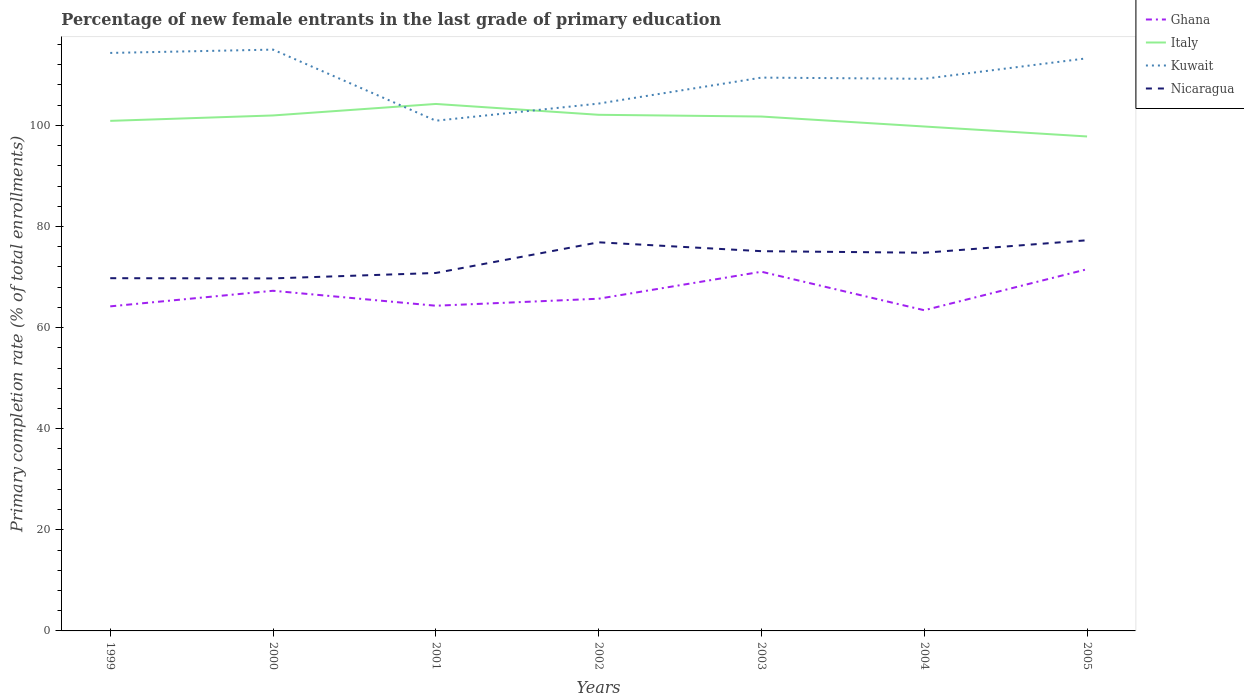How many different coloured lines are there?
Make the answer very short. 4. Across all years, what is the maximum percentage of new female entrants in Ghana?
Ensure brevity in your answer.  63.44. In which year was the percentage of new female entrants in Nicaragua maximum?
Offer a terse response. 2000. What is the total percentage of new female entrants in Ghana in the graph?
Your answer should be compact. -1.39. What is the difference between the highest and the second highest percentage of new female entrants in Kuwait?
Your response must be concise. 14.07. Is the percentage of new female entrants in Kuwait strictly greater than the percentage of new female entrants in Nicaragua over the years?
Keep it short and to the point. No. How many years are there in the graph?
Provide a succinct answer. 7. What is the difference between two consecutive major ticks on the Y-axis?
Give a very brief answer. 20. Are the values on the major ticks of Y-axis written in scientific E-notation?
Make the answer very short. No. Does the graph contain grids?
Your answer should be very brief. No. Where does the legend appear in the graph?
Your answer should be very brief. Top right. How many legend labels are there?
Ensure brevity in your answer.  4. What is the title of the graph?
Keep it short and to the point. Percentage of new female entrants in the last grade of primary education. What is the label or title of the Y-axis?
Offer a very short reply. Primary completion rate (% of total enrollments). What is the Primary completion rate (% of total enrollments) in Ghana in 1999?
Your answer should be very brief. 64.2. What is the Primary completion rate (% of total enrollments) in Italy in 1999?
Keep it short and to the point. 100.9. What is the Primary completion rate (% of total enrollments) of Kuwait in 1999?
Provide a short and direct response. 114.33. What is the Primary completion rate (% of total enrollments) of Nicaragua in 1999?
Keep it short and to the point. 69.77. What is the Primary completion rate (% of total enrollments) of Ghana in 2000?
Offer a very short reply. 67.29. What is the Primary completion rate (% of total enrollments) in Italy in 2000?
Offer a terse response. 101.97. What is the Primary completion rate (% of total enrollments) of Kuwait in 2000?
Make the answer very short. 114.99. What is the Primary completion rate (% of total enrollments) of Nicaragua in 2000?
Keep it short and to the point. 69.73. What is the Primary completion rate (% of total enrollments) of Ghana in 2001?
Your response must be concise. 64.33. What is the Primary completion rate (% of total enrollments) in Italy in 2001?
Offer a terse response. 104.24. What is the Primary completion rate (% of total enrollments) in Kuwait in 2001?
Provide a succinct answer. 100.93. What is the Primary completion rate (% of total enrollments) in Nicaragua in 2001?
Give a very brief answer. 70.81. What is the Primary completion rate (% of total enrollments) of Ghana in 2002?
Make the answer very short. 65.72. What is the Primary completion rate (% of total enrollments) of Italy in 2002?
Provide a short and direct response. 102.1. What is the Primary completion rate (% of total enrollments) of Kuwait in 2002?
Make the answer very short. 104.32. What is the Primary completion rate (% of total enrollments) in Nicaragua in 2002?
Give a very brief answer. 76.87. What is the Primary completion rate (% of total enrollments) in Ghana in 2003?
Offer a very short reply. 71.05. What is the Primary completion rate (% of total enrollments) of Italy in 2003?
Your answer should be very brief. 101.75. What is the Primary completion rate (% of total enrollments) of Kuwait in 2003?
Ensure brevity in your answer.  109.45. What is the Primary completion rate (% of total enrollments) of Nicaragua in 2003?
Your answer should be very brief. 75.12. What is the Primary completion rate (% of total enrollments) in Ghana in 2004?
Offer a very short reply. 63.44. What is the Primary completion rate (% of total enrollments) in Italy in 2004?
Make the answer very short. 99.78. What is the Primary completion rate (% of total enrollments) in Kuwait in 2004?
Ensure brevity in your answer.  109.22. What is the Primary completion rate (% of total enrollments) of Nicaragua in 2004?
Provide a short and direct response. 74.81. What is the Primary completion rate (% of total enrollments) in Ghana in 2005?
Offer a terse response. 71.55. What is the Primary completion rate (% of total enrollments) of Italy in 2005?
Your answer should be compact. 97.81. What is the Primary completion rate (% of total enrollments) of Kuwait in 2005?
Offer a terse response. 113.27. What is the Primary completion rate (% of total enrollments) of Nicaragua in 2005?
Provide a succinct answer. 77.28. Across all years, what is the maximum Primary completion rate (% of total enrollments) of Ghana?
Offer a terse response. 71.55. Across all years, what is the maximum Primary completion rate (% of total enrollments) in Italy?
Your answer should be compact. 104.24. Across all years, what is the maximum Primary completion rate (% of total enrollments) in Kuwait?
Provide a short and direct response. 114.99. Across all years, what is the maximum Primary completion rate (% of total enrollments) of Nicaragua?
Make the answer very short. 77.28. Across all years, what is the minimum Primary completion rate (% of total enrollments) of Ghana?
Keep it short and to the point. 63.44. Across all years, what is the minimum Primary completion rate (% of total enrollments) in Italy?
Your response must be concise. 97.81. Across all years, what is the minimum Primary completion rate (% of total enrollments) of Kuwait?
Ensure brevity in your answer.  100.93. Across all years, what is the minimum Primary completion rate (% of total enrollments) in Nicaragua?
Ensure brevity in your answer.  69.73. What is the total Primary completion rate (% of total enrollments) of Ghana in the graph?
Your answer should be compact. 467.57. What is the total Primary completion rate (% of total enrollments) of Italy in the graph?
Give a very brief answer. 708.55. What is the total Primary completion rate (% of total enrollments) in Kuwait in the graph?
Offer a terse response. 766.51. What is the total Primary completion rate (% of total enrollments) in Nicaragua in the graph?
Provide a succinct answer. 514.4. What is the difference between the Primary completion rate (% of total enrollments) in Ghana in 1999 and that in 2000?
Give a very brief answer. -3.08. What is the difference between the Primary completion rate (% of total enrollments) of Italy in 1999 and that in 2000?
Provide a succinct answer. -1.07. What is the difference between the Primary completion rate (% of total enrollments) of Kuwait in 1999 and that in 2000?
Your answer should be compact. -0.66. What is the difference between the Primary completion rate (% of total enrollments) in Nicaragua in 1999 and that in 2000?
Your response must be concise. 0.04. What is the difference between the Primary completion rate (% of total enrollments) in Ghana in 1999 and that in 2001?
Ensure brevity in your answer.  -0.12. What is the difference between the Primary completion rate (% of total enrollments) in Italy in 1999 and that in 2001?
Offer a terse response. -3.34. What is the difference between the Primary completion rate (% of total enrollments) in Kuwait in 1999 and that in 2001?
Offer a terse response. 13.41. What is the difference between the Primary completion rate (% of total enrollments) in Nicaragua in 1999 and that in 2001?
Your response must be concise. -1.03. What is the difference between the Primary completion rate (% of total enrollments) in Ghana in 1999 and that in 2002?
Your response must be concise. -1.51. What is the difference between the Primary completion rate (% of total enrollments) in Italy in 1999 and that in 2002?
Provide a short and direct response. -1.2. What is the difference between the Primary completion rate (% of total enrollments) of Kuwait in 1999 and that in 2002?
Make the answer very short. 10.02. What is the difference between the Primary completion rate (% of total enrollments) of Nicaragua in 1999 and that in 2002?
Offer a terse response. -7.1. What is the difference between the Primary completion rate (% of total enrollments) in Ghana in 1999 and that in 2003?
Your response must be concise. -6.85. What is the difference between the Primary completion rate (% of total enrollments) of Italy in 1999 and that in 2003?
Your answer should be compact. -0.86. What is the difference between the Primary completion rate (% of total enrollments) of Kuwait in 1999 and that in 2003?
Your response must be concise. 4.88. What is the difference between the Primary completion rate (% of total enrollments) of Nicaragua in 1999 and that in 2003?
Keep it short and to the point. -5.34. What is the difference between the Primary completion rate (% of total enrollments) in Ghana in 1999 and that in 2004?
Your response must be concise. 0.77. What is the difference between the Primary completion rate (% of total enrollments) of Italy in 1999 and that in 2004?
Make the answer very short. 1.12. What is the difference between the Primary completion rate (% of total enrollments) of Kuwait in 1999 and that in 2004?
Provide a succinct answer. 5.12. What is the difference between the Primary completion rate (% of total enrollments) of Nicaragua in 1999 and that in 2004?
Make the answer very short. -5.03. What is the difference between the Primary completion rate (% of total enrollments) in Ghana in 1999 and that in 2005?
Give a very brief answer. -7.34. What is the difference between the Primary completion rate (% of total enrollments) in Italy in 1999 and that in 2005?
Give a very brief answer. 3.09. What is the difference between the Primary completion rate (% of total enrollments) in Kuwait in 1999 and that in 2005?
Your response must be concise. 1.06. What is the difference between the Primary completion rate (% of total enrollments) in Nicaragua in 1999 and that in 2005?
Your response must be concise. -7.5. What is the difference between the Primary completion rate (% of total enrollments) of Ghana in 2000 and that in 2001?
Your answer should be very brief. 2.96. What is the difference between the Primary completion rate (% of total enrollments) in Italy in 2000 and that in 2001?
Provide a short and direct response. -2.27. What is the difference between the Primary completion rate (% of total enrollments) in Kuwait in 2000 and that in 2001?
Provide a short and direct response. 14.07. What is the difference between the Primary completion rate (% of total enrollments) of Nicaragua in 2000 and that in 2001?
Your response must be concise. -1.07. What is the difference between the Primary completion rate (% of total enrollments) in Ghana in 2000 and that in 2002?
Your answer should be very brief. 1.57. What is the difference between the Primary completion rate (% of total enrollments) of Italy in 2000 and that in 2002?
Your answer should be compact. -0.13. What is the difference between the Primary completion rate (% of total enrollments) of Kuwait in 2000 and that in 2002?
Your answer should be very brief. 10.68. What is the difference between the Primary completion rate (% of total enrollments) in Nicaragua in 2000 and that in 2002?
Your answer should be very brief. -7.14. What is the difference between the Primary completion rate (% of total enrollments) of Ghana in 2000 and that in 2003?
Keep it short and to the point. -3.77. What is the difference between the Primary completion rate (% of total enrollments) of Italy in 2000 and that in 2003?
Your answer should be compact. 0.21. What is the difference between the Primary completion rate (% of total enrollments) in Kuwait in 2000 and that in 2003?
Your answer should be compact. 5.54. What is the difference between the Primary completion rate (% of total enrollments) in Nicaragua in 2000 and that in 2003?
Provide a short and direct response. -5.38. What is the difference between the Primary completion rate (% of total enrollments) in Ghana in 2000 and that in 2004?
Offer a terse response. 3.85. What is the difference between the Primary completion rate (% of total enrollments) in Italy in 2000 and that in 2004?
Keep it short and to the point. 2.19. What is the difference between the Primary completion rate (% of total enrollments) of Kuwait in 2000 and that in 2004?
Your answer should be compact. 5.78. What is the difference between the Primary completion rate (% of total enrollments) of Nicaragua in 2000 and that in 2004?
Offer a terse response. -5.07. What is the difference between the Primary completion rate (% of total enrollments) in Ghana in 2000 and that in 2005?
Provide a short and direct response. -4.26. What is the difference between the Primary completion rate (% of total enrollments) in Italy in 2000 and that in 2005?
Give a very brief answer. 4.16. What is the difference between the Primary completion rate (% of total enrollments) of Kuwait in 2000 and that in 2005?
Offer a very short reply. 1.72. What is the difference between the Primary completion rate (% of total enrollments) in Nicaragua in 2000 and that in 2005?
Your answer should be very brief. -7.54. What is the difference between the Primary completion rate (% of total enrollments) in Ghana in 2001 and that in 2002?
Offer a very short reply. -1.39. What is the difference between the Primary completion rate (% of total enrollments) of Italy in 2001 and that in 2002?
Your answer should be compact. 2.14. What is the difference between the Primary completion rate (% of total enrollments) of Kuwait in 2001 and that in 2002?
Your answer should be compact. -3.39. What is the difference between the Primary completion rate (% of total enrollments) in Nicaragua in 2001 and that in 2002?
Make the answer very short. -6.07. What is the difference between the Primary completion rate (% of total enrollments) in Ghana in 2001 and that in 2003?
Give a very brief answer. -6.73. What is the difference between the Primary completion rate (% of total enrollments) in Italy in 2001 and that in 2003?
Provide a short and direct response. 2.49. What is the difference between the Primary completion rate (% of total enrollments) of Kuwait in 2001 and that in 2003?
Keep it short and to the point. -8.53. What is the difference between the Primary completion rate (% of total enrollments) of Nicaragua in 2001 and that in 2003?
Keep it short and to the point. -4.31. What is the difference between the Primary completion rate (% of total enrollments) in Ghana in 2001 and that in 2004?
Offer a very short reply. 0.89. What is the difference between the Primary completion rate (% of total enrollments) of Italy in 2001 and that in 2004?
Make the answer very short. 4.46. What is the difference between the Primary completion rate (% of total enrollments) of Kuwait in 2001 and that in 2004?
Provide a short and direct response. -8.29. What is the difference between the Primary completion rate (% of total enrollments) of Nicaragua in 2001 and that in 2004?
Keep it short and to the point. -4. What is the difference between the Primary completion rate (% of total enrollments) in Ghana in 2001 and that in 2005?
Give a very brief answer. -7.22. What is the difference between the Primary completion rate (% of total enrollments) in Italy in 2001 and that in 2005?
Your answer should be compact. 6.43. What is the difference between the Primary completion rate (% of total enrollments) of Kuwait in 2001 and that in 2005?
Your answer should be compact. -12.35. What is the difference between the Primary completion rate (% of total enrollments) of Nicaragua in 2001 and that in 2005?
Offer a terse response. -6.47. What is the difference between the Primary completion rate (% of total enrollments) of Ghana in 2002 and that in 2003?
Ensure brevity in your answer.  -5.34. What is the difference between the Primary completion rate (% of total enrollments) of Italy in 2002 and that in 2003?
Give a very brief answer. 0.34. What is the difference between the Primary completion rate (% of total enrollments) of Kuwait in 2002 and that in 2003?
Keep it short and to the point. -5.14. What is the difference between the Primary completion rate (% of total enrollments) of Nicaragua in 2002 and that in 2003?
Offer a very short reply. 1.76. What is the difference between the Primary completion rate (% of total enrollments) in Ghana in 2002 and that in 2004?
Provide a succinct answer. 2.28. What is the difference between the Primary completion rate (% of total enrollments) of Italy in 2002 and that in 2004?
Ensure brevity in your answer.  2.32. What is the difference between the Primary completion rate (% of total enrollments) of Kuwait in 2002 and that in 2004?
Make the answer very short. -4.9. What is the difference between the Primary completion rate (% of total enrollments) of Nicaragua in 2002 and that in 2004?
Make the answer very short. 2.06. What is the difference between the Primary completion rate (% of total enrollments) of Ghana in 2002 and that in 2005?
Provide a succinct answer. -5.83. What is the difference between the Primary completion rate (% of total enrollments) of Italy in 2002 and that in 2005?
Ensure brevity in your answer.  4.29. What is the difference between the Primary completion rate (% of total enrollments) of Kuwait in 2002 and that in 2005?
Make the answer very short. -8.96. What is the difference between the Primary completion rate (% of total enrollments) in Nicaragua in 2002 and that in 2005?
Offer a very short reply. -0.41. What is the difference between the Primary completion rate (% of total enrollments) in Ghana in 2003 and that in 2004?
Offer a terse response. 7.62. What is the difference between the Primary completion rate (% of total enrollments) of Italy in 2003 and that in 2004?
Give a very brief answer. 1.97. What is the difference between the Primary completion rate (% of total enrollments) of Kuwait in 2003 and that in 2004?
Provide a succinct answer. 0.24. What is the difference between the Primary completion rate (% of total enrollments) in Nicaragua in 2003 and that in 2004?
Provide a succinct answer. 0.31. What is the difference between the Primary completion rate (% of total enrollments) in Ghana in 2003 and that in 2005?
Keep it short and to the point. -0.49. What is the difference between the Primary completion rate (% of total enrollments) in Italy in 2003 and that in 2005?
Give a very brief answer. 3.94. What is the difference between the Primary completion rate (% of total enrollments) in Kuwait in 2003 and that in 2005?
Keep it short and to the point. -3.82. What is the difference between the Primary completion rate (% of total enrollments) in Nicaragua in 2003 and that in 2005?
Provide a succinct answer. -2.16. What is the difference between the Primary completion rate (% of total enrollments) of Ghana in 2004 and that in 2005?
Your response must be concise. -8.11. What is the difference between the Primary completion rate (% of total enrollments) of Italy in 2004 and that in 2005?
Your answer should be compact. 1.97. What is the difference between the Primary completion rate (% of total enrollments) of Kuwait in 2004 and that in 2005?
Keep it short and to the point. -4.06. What is the difference between the Primary completion rate (% of total enrollments) in Nicaragua in 2004 and that in 2005?
Make the answer very short. -2.47. What is the difference between the Primary completion rate (% of total enrollments) in Ghana in 1999 and the Primary completion rate (% of total enrollments) in Italy in 2000?
Your answer should be very brief. -37.76. What is the difference between the Primary completion rate (% of total enrollments) of Ghana in 1999 and the Primary completion rate (% of total enrollments) of Kuwait in 2000?
Offer a terse response. -50.79. What is the difference between the Primary completion rate (% of total enrollments) in Ghana in 1999 and the Primary completion rate (% of total enrollments) in Nicaragua in 2000?
Your answer should be very brief. -5.53. What is the difference between the Primary completion rate (% of total enrollments) of Italy in 1999 and the Primary completion rate (% of total enrollments) of Kuwait in 2000?
Your response must be concise. -14.1. What is the difference between the Primary completion rate (% of total enrollments) in Italy in 1999 and the Primary completion rate (% of total enrollments) in Nicaragua in 2000?
Provide a short and direct response. 31.16. What is the difference between the Primary completion rate (% of total enrollments) of Kuwait in 1999 and the Primary completion rate (% of total enrollments) of Nicaragua in 2000?
Make the answer very short. 44.6. What is the difference between the Primary completion rate (% of total enrollments) of Ghana in 1999 and the Primary completion rate (% of total enrollments) of Italy in 2001?
Offer a terse response. -40.04. What is the difference between the Primary completion rate (% of total enrollments) in Ghana in 1999 and the Primary completion rate (% of total enrollments) in Kuwait in 2001?
Provide a succinct answer. -36.72. What is the difference between the Primary completion rate (% of total enrollments) in Ghana in 1999 and the Primary completion rate (% of total enrollments) in Nicaragua in 2001?
Offer a very short reply. -6.6. What is the difference between the Primary completion rate (% of total enrollments) of Italy in 1999 and the Primary completion rate (% of total enrollments) of Kuwait in 2001?
Make the answer very short. -0.03. What is the difference between the Primary completion rate (% of total enrollments) of Italy in 1999 and the Primary completion rate (% of total enrollments) of Nicaragua in 2001?
Your answer should be very brief. 30.09. What is the difference between the Primary completion rate (% of total enrollments) in Kuwait in 1999 and the Primary completion rate (% of total enrollments) in Nicaragua in 2001?
Keep it short and to the point. 43.53. What is the difference between the Primary completion rate (% of total enrollments) of Ghana in 1999 and the Primary completion rate (% of total enrollments) of Italy in 2002?
Offer a very short reply. -37.89. What is the difference between the Primary completion rate (% of total enrollments) of Ghana in 1999 and the Primary completion rate (% of total enrollments) of Kuwait in 2002?
Give a very brief answer. -40.11. What is the difference between the Primary completion rate (% of total enrollments) of Ghana in 1999 and the Primary completion rate (% of total enrollments) of Nicaragua in 2002?
Your response must be concise. -12.67. What is the difference between the Primary completion rate (% of total enrollments) in Italy in 1999 and the Primary completion rate (% of total enrollments) in Kuwait in 2002?
Make the answer very short. -3.42. What is the difference between the Primary completion rate (% of total enrollments) of Italy in 1999 and the Primary completion rate (% of total enrollments) of Nicaragua in 2002?
Give a very brief answer. 24.02. What is the difference between the Primary completion rate (% of total enrollments) of Kuwait in 1999 and the Primary completion rate (% of total enrollments) of Nicaragua in 2002?
Provide a succinct answer. 37.46. What is the difference between the Primary completion rate (% of total enrollments) in Ghana in 1999 and the Primary completion rate (% of total enrollments) in Italy in 2003?
Keep it short and to the point. -37.55. What is the difference between the Primary completion rate (% of total enrollments) in Ghana in 1999 and the Primary completion rate (% of total enrollments) in Kuwait in 2003?
Give a very brief answer. -45.25. What is the difference between the Primary completion rate (% of total enrollments) of Ghana in 1999 and the Primary completion rate (% of total enrollments) of Nicaragua in 2003?
Offer a very short reply. -10.91. What is the difference between the Primary completion rate (% of total enrollments) in Italy in 1999 and the Primary completion rate (% of total enrollments) in Kuwait in 2003?
Ensure brevity in your answer.  -8.56. What is the difference between the Primary completion rate (% of total enrollments) of Italy in 1999 and the Primary completion rate (% of total enrollments) of Nicaragua in 2003?
Ensure brevity in your answer.  25.78. What is the difference between the Primary completion rate (% of total enrollments) in Kuwait in 1999 and the Primary completion rate (% of total enrollments) in Nicaragua in 2003?
Give a very brief answer. 39.22. What is the difference between the Primary completion rate (% of total enrollments) in Ghana in 1999 and the Primary completion rate (% of total enrollments) in Italy in 2004?
Keep it short and to the point. -35.58. What is the difference between the Primary completion rate (% of total enrollments) of Ghana in 1999 and the Primary completion rate (% of total enrollments) of Kuwait in 2004?
Your answer should be very brief. -45.01. What is the difference between the Primary completion rate (% of total enrollments) in Ghana in 1999 and the Primary completion rate (% of total enrollments) in Nicaragua in 2004?
Keep it short and to the point. -10.61. What is the difference between the Primary completion rate (% of total enrollments) in Italy in 1999 and the Primary completion rate (% of total enrollments) in Kuwait in 2004?
Keep it short and to the point. -8.32. What is the difference between the Primary completion rate (% of total enrollments) of Italy in 1999 and the Primary completion rate (% of total enrollments) of Nicaragua in 2004?
Your answer should be compact. 26.09. What is the difference between the Primary completion rate (% of total enrollments) in Kuwait in 1999 and the Primary completion rate (% of total enrollments) in Nicaragua in 2004?
Provide a succinct answer. 39.52. What is the difference between the Primary completion rate (% of total enrollments) of Ghana in 1999 and the Primary completion rate (% of total enrollments) of Italy in 2005?
Provide a short and direct response. -33.61. What is the difference between the Primary completion rate (% of total enrollments) of Ghana in 1999 and the Primary completion rate (% of total enrollments) of Kuwait in 2005?
Provide a short and direct response. -49.07. What is the difference between the Primary completion rate (% of total enrollments) of Ghana in 1999 and the Primary completion rate (% of total enrollments) of Nicaragua in 2005?
Keep it short and to the point. -13.08. What is the difference between the Primary completion rate (% of total enrollments) in Italy in 1999 and the Primary completion rate (% of total enrollments) in Kuwait in 2005?
Provide a succinct answer. -12.38. What is the difference between the Primary completion rate (% of total enrollments) of Italy in 1999 and the Primary completion rate (% of total enrollments) of Nicaragua in 2005?
Offer a very short reply. 23.62. What is the difference between the Primary completion rate (% of total enrollments) in Kuwait in 1999 and the Primary completion rate (% of total enrollments) in Nicaragua in 2005?
Your answer should be very brief. 37.06. What is the difference between the Primary completion rate (% of total enrollments) of Ghana in 2000 and the Primary completion rate (% of total enrollments) of Italy in 2001?
Offer a very short reply. -36.96. What is the difference between the Primary completion rate (% of total enrollments) in Ghana in 2000 and the Primary completion rate (% of total enrollments) in Kuwait in 2001?
Keep it short and to the point. -33.64. What is the difference between the Primary completion rate (% of total enrollments) of Ghana in 2000 and the Primary completion rate (% of total enrollments) of Nicaragua in 2001?
Your response must be concise. -3.52. What is the difference between the Primary completion rate (% of total enrollments) of Italy in 2000 and the Primary completion rate (% of total enrollments) of Kuwait in 2001?
Offer a very short reply. 1.04. What is the difference between the Primary completion rate (% of total enrollments) of Italy in 2000 and the Primary completion rate (% of total enrollments) of Nicaragua in 2001?
Offer a terse response. 31.16. What is the difference between the Primary completion rate (% of total enrollments) in Kuwait in 2000 and the Primary completion rate (% of total enrollments) in Nicaragua in 2001?
Provide a short and direct response. 44.18. What is the difference between the Primary completion rate (% of total enrollments) in Ghana in 2000 and the Primary completion rate (% of total enrollments) in Italy in 2002?
Offer a terse response. -34.81. What is the difference between the Primary completion rate (% of total enrollments) of Ghana in 2000 and the Primary completion rate (% of total enrollments) of Kuwait in 2002?
Your response must be concise. -37.03. What is the difference between the Primary completion rate (% of total enrollments) of Ghana in 2000 and the Primary completion rate (% of total enrollments) of Nicaragua in 2002?
Make the answer very short. -9.59. What is the difference between the Primary completion rate (% of total enrollments) in Italy in 2000 and the Primary completion rate (% of total enrollments) in Kuwait in 2002?
Provide a short and direct response. -2.35. What is the difference between the Primary completion rate (% of total enrollments) of Italy in 2000 and the Primary completion rate (% of total enrollments) of Nicaragua in 2002?
Your answer should be very brief. 25.09. What is the difference between the Primary completion rate (% of total enrollments) in Kuwait in 2000 and the Primary completion rate (% of total enrollments) in Nicaragua in 2002?
Your response must be concise. 38.12. What is the difference between the Primary completion rate (% of total enrollments) in Ghana in 2000 and the Primary completion rate (% of total enrollments) in Italy in 2003?
Offer a very short reply. -34.47. What is the difference between the Primary completion rate (% of total enrollments) in Ghana in 2000 and the Primary completion rate (% of total enrollments) in Kuwait in 2003?
Offer a terse response. -42.17. What is the difference between the Primary completion rate (% of total enrollments) of Ghana in 2000 and the Primary completion rate (% of total enrollments) of Nicaragua in 2003?
Your response must be concise. -7.83. What is the difference between the Primary completion rate (% of total enrollments) of Italy in 2000 and the Primary completion rate (% of total enrollments) of Kuwait in 2003?
Keep it short and to the point. -7.49. What is the difference between the Primary completion rate (% of total enrollments) in Italy in 2000 and the Primary completion rate (% of total enrollments) in Nicaragua in 2003?
Make the answer very short. 26.85. What is the difference between the Primary completion rate (% of total enrollments) of Kuwait in 2000 and the Primary completion rate (% of total enrollments) of Nicaragua in 2003?
Ensure brevity in your answer.  39.87. What is the difference between the Primary completion rate (% of total enrollments) in Ghana in 2000 and the Primary completion rate (% of total enrollments) in Italy in 2004?
Your response must be concise. -32.5. What is the difference between the Primary completion rate (% of total enrollments) in Ghana in 2000 and the Primary completion rate (% of total enrollments) in Kuwait in 2004?
Make the answer very short. -41.93. What is the difference between the Primary completion rate (% of total enrollments) in Ghana in 2000 and the Primary completion rate (% of total enrollments) in Nicaragua in 2004?
Ensure brevity in your answer.  -7.52. What is the difference between the Primary completion rate (% of total enrollments) in Italy in 2000 and the Primary completion rate (% of total enrollments) in Kuwait in 2004?
Your answer should be very brief. -7.25. What is the difference between the Primary completion rate (% of total enrollments) in Italy in 2000 and the Primary completion rate (% of total enrollments) in Nicaragua in 2004?
Your answer should be very brief. 27.16. What is the difference between the Primary completion rate (% of total enrollments) of Kuwait in 2000 and the Primary completion rate (% of total enrollments) of Nicaragua in 2004?
Keep it short and to the point. 40.18. What is the difference between the Primary completion rate (% of total enrollments) in Ghana in 2000 and the Primary completion rate (% of total enrollments) in Italy in 2005?
Keep it short and to the point. -30.53. What is the difference between the Primary completion rate (% of total enrollments) in Ghana in 2000 and the Primary completion rate (% of total enrollments) in Kuwait in 2005?
Provide a succinct answer. -45.99. What is the difference between the Primary completion rate (% of total enrollments) of Ghana in 2000 and the Primary completion rate (% of total enrollments) of Nicaragua in 2005?
Provide a succinct answer. -9.99. What is the difference between the Primary completion rate (% of total enrollments) in Italy in 2000 and the Primary completion rate (% of total enrollments) in Kuwait in 2005?
Keep it short and to the point. -11.31. What is the difference between the Primary completion rate (% of total enrollments) of Italy in 2000 and the Primary completion rate (% of total enrollments) of Nicaragua in 2005?
Your response must be concise. 24.69. What is the difference between the Primary completion rate (% of total enrollments) in Kuwait in 2000 and the Primary completion rate (% of total enrollments) in Nicaragua in 2005?
Your answer should be very brief. 37.71. What is the difference between the Primary completion rate (% of total enrollments) of Ghana in 2001 and the Primary completion rate (% of total enrollments) of Italy in 2002?
Your response must be concise. -37.77. What is the difference between the Primary completion rate (% of total enrollments) of Ghana in 2001 and the Primary completion rate (% of total enrollments) of Kuwait in 2002?
Offer a terse response. -39.99. What is the difference between the Primary completion rate (% of total enrollments) of Ghana in 2001 and the Primary completion rate (% of total enrollments) of Nicaragua in 2002?
Offer a terse response. -12.55. What is the difference between the Primary completion rate (% of total enrollments) of Italy in 2001 and the Primary completion rate (% of total enrollments) of Kuwait in 2002?
Keep it short and to the point. -0.08. What is the difference between the Primary completion rate (% of total enrollments) of Italy in 2001 and the Primary completion rate (% of total enrollments) of Nicaragua in 2002?
Your response must be concise. 27.37. What is the difference between the Primary completion rate (% of total enrollments) in Kuwait in 2001 and the Primary completion rate (% of total enrollments) in Nicaragua in 2002?
Provide a short and direct response. 24.05. What is the difference between the Primary completion rate (% of total enrollments) in Ghana in 2001 and the Primary completion rate (% of total enrollments) in Italy in 2003?
Keep it short and to the point. -37.43. What is the difference between the Primary completion rate (% of total enrollments) of Ghana in 2001 and the Primary completion rate (% of total enrollments) of Kuwait in 2003?
Give a very brief answer. -45.13. What is the difference between the Primary completion rate (% of total enrollments) in Ghana in 2001 and the Primary completion rate (% of total enrollments) in Nicaragua in 2003?
Keep it short and to the point. -10.79. What is the difference between the Primary completion rate (% of total enrollments) in Italy in 2001 and the Primary completion rate (% of total enrollments) in Kuwait in 2003?
Offer a very short reply. -5.21. What is the difference between the Primary completion rate (% of total enrollments) in Italy in 2001 and the Primary completion rate (% of total enrollments) in Nicaragua in 2003?
Keep it short and to the point. 29.12. What is the difference between the Primary completion rate (% of total enrollments) in Kuwait in 2001 and the Primary completion rate (% of total enrollments) in Nicaragua in 2003?
Your answer should be very brief. 25.81. What is the difference between the Primary completion rate (% of total enrollments) in Ghana in 2001 and the Primary completion rate (% of total enrollments) in Italy in 2004?
Your response must be concise. -35.45. What is the difference between the Primary completion rate (% of total enrollments) of Ghana in 2001 and the Primary completion rate (% of total enrollments) of Kuwait in 2004?
Keep it short and to the point. -44.89. What is the difference between the Primary completion rate (% of total enrollments) of Ghana in 2001 and the Primary completion rate (% of total enrollments) of Nicaragua in 2004?
Provide a short and direct response. -10.48. What is the difference between the Primary completion rate (% of total enrollments) in Italy in 2001 and the Primary completion rate (% of total enrollments) in Kuwait in 2004?
Offer a terse response. -4.98. What is the difference between the Primary completion rate (% of total enrollments) of Italy in 2001 and the Primary completion rate (% of total enrollments) of Nicaragua in 2004?
Your answer should be compact. 29.43. What is the difference between the Primary completion rate (% of total enrollments) in Kuwait in 2001 and the Primary completion rate (% of total enrollments) in Nicaragua in 2004?
Provide a succinct answer. 26.12. What is the difference between the Primary completion rate (% of total enrollments) in Ghana in 2001 and the Primary completion rate (% of total enrollments) in Italy in 2005?
Your response must be concise. -33.48. What is the difference between the Primary completion rate (% of total enrollments) in Ghana in 2001 and the Primary completion rate (% of total enrollments) in Kuwait in 2005?
Offer a very short reply. -48.95. What is the difference between the Primary completion rate (% of total enrollments) of Ghana in 2001 and the Primary completion rate (% of total enrollments) of Nicaragua in 2005?
Offer a very short reply. -12.95. What is the difference between the Primary completion rate (% of total enrollments) of Italy in 2001 and the Primary completion rate (% of total enrollments) of Kuwait in 2005?
Your answer should be very brief. -9.03. What is the difference between the Primary completion rate (% of total enrollments) in Italy in 2001 and the Primary completion rate (% of total enrollments) in Nicaragua in 2005?
Offer a terse response. 26.96. What is the difference between the Primary completion rate (% of total enrollments) of Kuwait in 2001 and the Primary completion rate (% of total enrollments) of Nicaragua in 2005?
Offer a very short reply. 23.65. What is the difference between the Primary completion rate (% of total enrollments) of Ghana in 2002 and the Primary completion rate (% of total enrollments) of Italy in 2003?
Make the answer very short. -36.04. What is the difference between the Primary completion rate (% of total enrollments) of Ghana in 2002 and the Primary completion rate (% of total enrollments) of Kuwait in 2003?
Provide a short and direct response. -43.74. What is the difference between the Primary completion rate (% of total enrollments) of Ghana in 2002 and the Primary completion rate (% of total enrollments) of Nicaragua in 2003?
Make the answer very short. -9.4. What is the difference between the Primary completion rate (% of total enrollments) of Italy in 2002 and the Primary completion rate (% of total enrollments) of Kuwait in 2003?
Your response must be concise. -7.36. What is the difference between the Primary completion rate (% of total enrollments) in Italy in 2002 and the Primary completion rate (% of total enrollments) in Nicaragua in 2003?
Keep it short and to the point. 26.98. What is the difference between the Primary completion rate (% of total enrollments) of Kuwait in 2002 and the Primary completion rate (% of total enrollments) of Nicaragua in 2003?
Keep it short and to the point. 29.2. What is the difference between the Primary completion rate (% of total enrollments) in Ghana in 2002 and the Primary completion rate (% of total enrollments) in Italy in 2004?
Give a very brief answer. -34.07. What is the difference between the Primary completion rate (% of total enrollments) in Ghana in 2002 and the Primary completion rate (% of total enrollments) in Kuwait in 2004?
Provide a short and direct response. -43.5. What is the difference between the Primary completion rate (% of total enrollments) of Ghana in 2002 and the Primary completion rate (% of total enrollments) of Nicaragua in 2004?
Offer a terse response. -9.09. What is the difference between the Primary completion rate (% of total enrollments) in Italy in 2002 and the Primary completion rate (% of total enrollments) in Kuwait in 2004?
Your response must be concise. -7.12. What is the difference between the Primary completion rate (% of total enrollments) of Italy in 2002 and the Primary completion rate (% of total enrollments) of Nicaragua in 2004?
Offer a terse response. 27.29. What is the difference between the Primary completion rate (% of total enrollments) of Kuwait in 2002 and the Primary completion rate (% of total enrollments) of Nicaragua in 2004?
Offer a very short reply. 29.51. What is the difference between the Primary completion rate (% of total enrollments) in Ghana in 2002 and the Primary completion rate (% of total enrollments) in Italy in 2005?
Provide a succinct answer. -32.1. What is the difference between the Primary completion rate (% of total enrollments) of Ghana in 2002 and the Primary completion rate (% of total enrollments) of Kuwait in 2005?
Your answer should be very brief. -47.56. What is the difference between the Primary completion rate (% of total enrollments) in Ghana in 2002 and the Primary completion rate (% of total enrollments) in Nicaragua in 2005?
Your response must be concise. -11.56. What is the difference between the Primary completion rate (% of total enrollments) in Italy in 2002 and the Primary completion rate (% of total enrollments) in Kuwait in 2005?
Ensure brevity in your answer.  -11.18. What is the difference between the Primary completion rate (% of total enrollments) of Italy in 2002 and the Primary completion rate (% of total enrollments) of Nicaragua in 2005?
Your answer should be compact. 24.82. What is the difference between the Primary completion rate (% of total enrollments) in Kuwait in 2002 and the Primary completion rate (% of total enrollments) in Nicaragua in 2005?
Offer a terse response. 27.04. What is the difference between the Primary completion rate (% of total enrollments) in Ghana in 2003 and the Primary completion rate (% of total enrollments) in Italy in 2004?
Your response must be concise. -28.73. What is the difference between the Primary completion rate (% of total enrollments) of Ghana in 2003 and the Primary completion rate (% of total enrollments) of Kuwait in 2004?
Keep it short and to the point. -38.16. What is the difference between the Primary completion rate (% of total enrollments) of Ghana in 2003 and the Primary completion rate (% of total enrollments) of Nicaragua in 2004?
Your response must be concise. -3.75. What is the difference between the Primary completion rate (% of total enrollments) of Italy in 2003 and the Primary completion rate (% of total enrollments) of Kuwait in 2004?
Offer a very short reply. -7.46. What is the difference between the Primary completion rate (% of total enrollments) of Italy in 2003 and the Primary completion rate (% of total enrollments) of Nicaragua in 2004?
Ensure brevity in your answer.  26.95. What is the difference between the Primary completion rate (% of total enrollments) in Kuwait in 2003 and the Primary completion rate (% of total enrollments) in Nicaragua in 2004?
Offer a terse response. 34.64. What is the difference between the Primary completion rate (% of total enrollments) in Ghana in 2003 and the Primary completion rate (% of total enrollments) in Italy in 2005?
Make the answer very short. -26.76. What is the difference between the Primary completion rate (% of total enrollments) of Ghana in 2003 and the Primary completion rate (% of total enrollments) of Kuwait in 2005?
Ensure brevity in your answer.  -42.22. What is the difference between the Primary completion rate (% of total enrollments) in Ghana in 2003 and the Primary completion rate (% of total enrollments) in Nicaragua in 2005?
Offer a terse response. -6.22. What is the difference between the Primary completion rate (% of total enrollments) of Italy in 2003 and the Primary completion rate (% of total enrollments) of Kuwait in 2005?
Provide a short and direct response. -11.52. What is the difference between the Primary completion rate (% of total enrollments) of Italy in 2003 and the Primary completion rate (% of total enrollments) of Nicaragua in 2005?
Your response must be concise. 24.48. What is the difference between the Primary completion rate (% of total enrollments) of Kuwait in 2003 and the Primary completion rate (% of total enrollments) of Nicaragua in 2005?
Your answer should be very brief. 32.18. What is the difference between the Primary completion rate (% of total enrollments) of Ghana in 2004 and the Primary completion rate (% of total enrollments) of Italy in 2005?
Your answer should be compact. -34.37. What is the difference between the Primary completion rate (% of total enrollments) of Ghana in 2004 and the Primary completion rate (% of total enrollments) of Kuwait in 2005?
Ensure brevity in your answer.  -49.83. What is the difference between the Primary completion rate (% of total enrollments) of Ghana in 2004 and the Primary completion rate (% of total enrollments) of Nicaragua in 2005?
Your answer should be very brief. -13.84. What is the difference between the Primary completion rate (% of total enrollments) of Italy in 2004 and the Primary completion rate (% of total enrollments) of Kuwait in 2005?
Offer a terse response. -13.49. What is the difference between the Primary completion rate (% of total enrollments) of Italy in 2004 and the Primary completion rate (% of total enrollments) of Nicaragua in 2005?
Make the answer very short. 22.5. What is the difference between the Primary completion rate (% of total enrollments) of Kuwait in 2004 and the Primary completion rate (% of total enrollments) of Nicaragua in 2005?
Your response must be concise. 31.94. What is the average Primary completion rate (% of total enrollments) of Ghana per year?
Ensure brevity in your answer.  66.8. What is the average Primary completion rate (% of total enrollments) in Italy per year?
Provide a short and direct response. 101.22. What is the average Primary completion rate (% of total enrollments) of Kuwait per year?
Your answer should be very brief. 109.5. What is the average Primary completion rate (% of total enrollments) in Nicaragua per year?
Offer a terse response. 73.49. In the year 1999, what is the difference between the Primary completion rate (% of total enrollments) in Ghana and Primary completion rate (% of total enrollments) in Italy?
Offer a terse response. -36.69. In the year 1999, what is the difference between the Primary completion rate (% of total enrollments) of Ghana and Primary completion rate (% of total enrollments) of Kuwait?
Offer a terse response. -50.13. In the year 1999, what is the difference between the Primary completion rate (% of total enrollments) of Ghana and Primary completion rate (% of total enrollments) of Nicaragua?
Ensure brevity in your answer.  -5.57. In the year 1999, what is the difference between the Primary completion rate (% of total enrollments) of Italy and Primary completion rate (% of total enrollments) of Kuwait?
Offer a very short reply. -13.44. In the year 1999, what is the difference between the Primary completion rate (% of total enrollments) in Italy and Primary completion rate (% of total enrollments) in Nicaragua?
Provide a short and direct response. 31.12. In the year 1999, what is the difference between the Primary completion rate (% of total enrollments) in Kuwait and Primary completion rate (% of total enrollments) in Nicaragua?
Your answer should be very brief. 44.56. In the year 2000, what is the difference between the Primary completion rate (% of total enrollments) in Ghana and Primary completion rate (% of total enrollments) in Italy?
Provide a succinct answer. -34.68. In the year 2000, what is the difference between the Primary completion rate (% of total enrollments) of Ghana and Primary completion rate (% of total enrollments) of Kuwait?
Offer a very short reply. -47.71. In the year 2000, what is the difference between the Primary completion rate (% of total enrollments) in Ghana and Primary completion rate (% of total enrollments) in Nicaragua?
Make the answer very short. -2.45. In the year 2000, what is the difference between the Primary completion rate (% of total enrollments) of Italy and Primary completion rate (% of total enrollments) of Kuwait?
Your answer should be compact. -13.03. In the year 2000, what is the difference between the Primary completion rate (% of total enrollments) of Italy and Primary completion rate (% of total enrollments) of Nicaragua?
Ensure brevity in your answer.  32.23. In the year 2000, what is the difference between the Primary completion rate (% of total enrollments) of Kuwait and Primary completion rate (% of total enrollments) of Nicaragua?
Ensure brevity in your answer.  45.26. In the year 2001, what is the difference between the Primary completion rate (% of total enrollments) in Ghana and Primary completion rate (% of total enrollments) in Italy?
Your response must be concise. -39.91. In the year 2001, what is the difference between the Primary completion rate (% of total enrollments) of Ghana and Primary completion rate (% of total enrollments) of Kuwait?
Keep it short and to the point. -36.6. In the year 2001, what is the difference between the Primary completion rate (% of total enrollments) of Ghana and Primary completion rate (% of total enrollments) of Nicaragua?
Your answer should be very brief. -6.48. In the year 2001, what is the difference between the Primary completion rate (% of total enrollments) in Italy and Primary completion rate (% of total enrollments) in Kuwait?
Offer a very short reply. 3.32. In the year 2001, what is the difference between the Primary completion rate (% of total enrollments) in Italy and Primary completion rate (% of total enrollments) in Nicaragua?
Ensure brevity in your answer.  33.43. In the year 2001, what is the difference between the Primary completion rate (% of total enrollments) in Kuwait and Primary completion rate (% of total enrollments) in Nicaragua?
Your response must be concise. 30.12. In the year 2002, what is the difference between the Primary completion rate (% of total enrollments) in Ghana and Primary completion rate (% of total enrollments) in Italy?
Keep it short and to the point. -36.38. In the year 2002, what is the difference between the Primary completion rate (% of total enrollments) of Ghana and Primary completion rate (% of total enrollments) of Kuwait?
Make the answer very short. -38.6. In the year 2002, what is the difference between the Primary completion rate (% of total enrollments) in Ghana and Primary completion rate (% of total enrollments) in Nicaragua?
Offer a terse response. -11.16. In the year 2002, what is the difference between the Primary completion rate (% of total enrollments) in Italy and Primary completion rate (% of total enrollments) in Kuwait?
Provide a short and direct response. -2.22. In the year 2002, what is the difference between the Primary completion rate (% of total enrollments) in Italy and Primary completion rate (% of total enrollments) in Nicaragua?
Keep it short and to the point. 25.22. In the year 2002, what is the difference between the Primary completion rate (% of total enrollments) of Kuwait and Primary completion rate (% of total enrollments) of Nicaragua?
Offer a very short reply. 27.44. In the year 2003, what is the difference between the Primary completion rate (% of total enrollments) of Ghana and Primary completion rate (% of total enrollments) of Italy?
Your response must be concise. -30.7. In the year 2003, what is the difference between the Primary completion rate (% of total enrollments) of Ghana and Primary completion rate (% of total enrollments) of Kuwait?
Provide a succinct answer. -38.4. In the year 2003, what is the difference between the Primary completion rate (% of total enrollments) of Ghana and Primary completion rate (% of total enrollments) of Nicaragua?
Make the answer very short. -4.06. In the year 2003, what is the difference between the Primary completion rate (% of total enrollments) of Italy and Primary completion rate (% of total enrollments) of Kuwait?
Offer a terse response. -7.7. In the year 2003, what is the difference between the Primary completion rate (% of total enrollments) of Italy and Primary completion rate (% of total enrollments) of Nicaragua?
Give a very brief answer. 26.64. In the year 2003, what is the difference between the Primary completion rate (% of total enrollments) in Kuwait and Primary completion rate (% of total enrollments) in Nicaragua?
Keep it short and to the point. 34.34. In the year 2004, what is the difference between the Primary completion rate (% of total enrollments) of Ghana and Primary completion rate (% of total enrollments) of Italy?
Offer a very short reply. -36.34. In the year 2004, what is the difference between the Primary completion rate (% of total enrollments) of Ghana and Primary completion rate (% of total enrollments) of Kuwait?
Your response must be concise. -45.78. In the year 2004, what is the difference between the Primary completion rate (% of total enrollments) in Ghana and Primary completion rate (% of total enrollments) in Nicaragua?
Provide a short and direct response. -11.37. In the year 2004, what is the difference between the Primary completion rate (% of total enrollments) of Italy and Primary completion rate (% of total enrollments) of Kuwait?
Make the answer very short. -9.44. In the year 2004, what is the difference between the Primary completion rate (% of total enrollments) in Italy and Primary completion rate (% of total enrollments) in Nicaragua?
Your answer should be compact. 24.97. In the year 2004, what is the difference between the Primary completion rate (% of total enrollments) in Kuwait and Primary completion rate (% of total enrollments) in Nicaragua?
Offer a very short reply. 34.41. In the year 2005, what is the difference between the Primary completion rate (% of total enrollments) of Ghana and Primary completion rate (% of total enrollments) of Italy?
Provide a succinct answer. -26.26. In the year 2005, what is the difference between the Primary completion rate (% of total enrollments) of Ghana and Primary completion rate (% of total enrollments) of Kuwait?
Provide a succinct answer. -41.73. In the year 2005, what is the difference between the Primary completion rate (% of total enrollments) of Ghana and Primary completion rate (% of total enrollments) of Nicaragua?
Keep it short and to the point. -5.73. In the year 2005, what is the difference between the Primary completion rate (% of total enrollments) of Italy and Primary completion rate (% of total enrollments) of Kuwait?
Your response must be concise. -15.46. In the year 2005, what is the difference between the Primary completion rate (% of total enrollments) of Italy and Primary completion rate (% of total enrollments) of Nicaragua?
Ensure brevity in your answer.  20.53. In the year 2005, what is the difference between the Primary completion rate (% of total enrollments) of Kuwait and Primary completion rate (% of total enrollments) of Nicaragua?
Your response must be concise. 35.99. What is the ratio of the Primary completion rate (% of total enrollments) of Ghana in 1999 to that in 2000?
Provide a short and direct response. 0.95. What is the ratio of the Primary completion rate (% of total enrollments) of Italy in 1999 to that in 2000?
Offer a terse response. 0.99. What is the ratio of the Primary completion rate (% of total enrollments) in Kuwait in 1999 to that in 2000?
Provide a short and direct response. 0.99. What is the ratio of the Primary completion rate (% of total enrollments) in Nicaragua in 1999 to that in 2000?
Offer a very short reply. 1. What is the ratio of the Primary completion rate (% of total enrollments) in Italy in 1999 to that in 2001?
Keep it short and to the point. 0.97. What is the ratio of the Primary completion rate (% of total enrollments) in Kuwait in 1999 to that in 2001?
Your answer should be compact. 1.13. What is the ratio of the Primary completion rate (% of total enrollments) of Nicaragua in 1999 to that in 2001?
Provide a short and direct response. 0.99. What is the ratio of the Primary completion rate (% of total enrollments) of Italy in 1999 to that in 2002?
Your answer should be very brief. 0.99. What is the ratio of the Primary completion rate (% of total enrollments) in Kuwait in 1999 to that in 2002?
Offer a terse response. 1.1. What is the ratio of the Primary completion rate (% of total enrollments) of Nicaragua in 1999 to that in 2002?
Give a very brief answer. 0.91. What is the ratio of the Primary completion rate (% of total enrollments) of Ghana in 1999 to that in 2003?
Your answer should be very brief. 0.9. What is the ratio of the Primary completion rate (% of total enrollments) in Kuwait in 1999 to that in 2003?
Offer a terse response. 1.04. What is the ratio of the Primary completion rate (% of total enrollments) of Nicaragua in 1999 to that in 2003?
Your answer should be compact. 0.93. What is the ratio of the Primary completion rate (% of total enrollments) in Ghana in 1999 to that in 2004?
Offer a very short reply. 1.01. What is the ratio of the Primary completion rate (% of total enrollments) in Italy in 1999 to that in 2004?
Provide a short and direct response. 1.01. What is the ratio of the Primary completion rate (% of total enrollments) in Kuwait in 1999 to that in 2004?
Offer a very short reply. 1.05. What is the ratio of the Primary completion rate (% of total enrollments) of Nicaragua in 1999 to that in 2004?
Keep it short and to the point. 0.93. What is the ratio of the Primary completion rate (% of total enrollments) in Ghana in 1999 to that in 2005?
Offer a terse response. 0.9. What is the ratio of the Primary completion rate (% of total enrollments) of Italy in 1999 to that in 2005?
Provide a short and direct response. 1.03. What is the ratio of the Primary completion rate (% of total enrollments) in Kuwait in 1999 to that in 2005?
Keep it short and to the point. 1.01. What is the ratio of the Primary completion rate (% of total enrollments) of Nicaragua in 1999 to that in 2005?
Keep it short and to the point. 0.9. What is the ratio of the Primary completion rate (% of total enrollments) in Ghana in 2000 to that in 2001?
Your answer should be very brief. 1.05. What is the ratio of the Primary completion rate (% of total enrollments) in Italy in 2000 to that in 2001?
Your response must be concise. 0.98. What is the ratio of the Primary completion rate (% of total enrollments) in Kuwait in 2000 to that in 2001?
Ensure brevity in your answer.  1.14. What is the ratio of the Primary completion rate (% of total enrollments) of Ghana in 2000 to that in 2002?
Make the answer very short. 1.02. What is the ratio of the Primary completion rate (% of total enrollments) in Italy in 2000 to that in 2002?
Keep it short and to the point. 1. What is the ratio of the Primary completion rate (% of total enrollments) in Kuwait in 2000 to that in 2002?
Your answer should be compact. 1.1. What is the ratio of the Primary completion rate (% of total enrollments) of Nicaragua in 2000 to that in 2002?
Provide a succinct answer. 0.91. What is the ratio of the Primary completion rate (% of total enrollments) of Ghana in 2000 to that in 2003?
Provide a short and direct response. 0.95. What is the ratio of the Primary completion rate (% of total enrollments) of Kuwait in 2000 to that in 2003?
Make the answer very short. 1.05. What is the ratio of the Primary completion rate (% of total enrollments) in Nicaragua in 2000 to that in 2003?
Offer a terse response. 0.93. What is the ratio of the Primary completion rate (% of total enrollments) of Ghana in 2000 to that in 2004?
Keep it short and to the point. 1.06. What is the ratio of the Primary completion rate (% of total enrollments) of Italy in 2000 to that in 2004?
Keep it short and to the point. 1.02. What is the ratio of the Primary completion rate (% of total enrollments) of Kuwait in 2000 to that in 2004?
Your answer should be compact. 1.05. What is the ratio of the Primary completion rate (% of total enrollments) in Nicaragua in 2000 to that in 2004?
Provide a short and direct response. 0.93. What is the ratio of the Primary completion rate (% of total enrollments) in Ghana in 2000 to that in 2005?
Ensure brevity in your answer.  0.94. What is the ratio of the Primary completion rate (% of total enrollments) of Italy in 2000 to that in 2005?
Keep it short and to the point. 1.04. What is the ratio of the Primary completion rate (% of total enrollments) of Kuwait in 2000 to that in 2005?
Ensure brevity in your answer.  1.02. What is the ratio of the Primary completion rate (% of total enrollments) in Nicaragua in 2000 to that in 2005?
Provide a short and direct response. 0.9. What is the ratio of the Primary completion rate (% of total enrollments) in Ghana in 2001 to that in 2002?
Keep it short and to the point. 0.98. What is the ratio of the Primary completion rate (% of total enrollments) in Italy in 2001 to that in 2002?
Provide a short and direct response. 1.02. What is the ratio of the Primary completion rate (% of total enrollments) of Kuwait in 2001 to that in 2002?
Offer a very short reply. 0.97. What is the ratio of the Primary completion rate (% of total enrollments) of Nicaragua in 2001 to that in 2002?
Ensure brevity in your answer.  0.92. What is the ratio of the Primary completion rate (% of total enrollments) in Ghana in 2001 to that in 2003?
Ensure brevity in your answer.  0.91. What is the ratio of the Primary completion rate (% of total enrollments) of Italy in 2001 to that in 2003?
Your answer should be compact. 1.02. What is the ratio of the Primary completion rate (% of total enrollments) in Kuwait in 2001 to that in 2003?
Your response must be concise. 0.92. What is the ratio of the Primary completion rate (% of total enrollments) of Nicaragua in 2001 to that in 2003?
Ensure brevity in your answer.  0.94. What is the ratio of the Primary completion rate (% of total enrollments) in Italy in 2001 to that in 2004?
Make the answer very short. 1.04. What is the ratio of the Primary completion rate (% of total enrollments) in Kuwait in 2001 to that in 2004?
Provide a succinct answer. 0.92. What is the ratio of the Primary completion rate (% of total enrollments) of Nicaragua in 2001 to that in 2004?
Ensure brevity in your answer.  0.95. What is the ratio of the Primary completion rate (% of total enrollments) of Ghana in 2001 to that in 2005?
Give a very brief answer. 0.9. What is the ratio of the Primary completion rate (% of total enrollments) of Italy in 2001 to that in 2005?
Provide a succinct answer. 1.07. What is the ratio of the Primary completion rate (% of total enrollments) in Kuwait in 2001 to that in 2005?
Your answer should be compact. 0.89. What is the ratio of the Primary completion rate (% of total enrollments) of Nicaragua in 2001 to that in 2005?
Make the answer very short. 0.92. What is the ratio of the Primary completion rate (% of total enrollments) of Ghana in 2002 to that in 2003?
Provide a succinct answer. 0.92. What is the ratio of the Primary completion rate (% of total enrollments) of Kuwait in 2002 to that in 2003?
Your response must be concise. 0.95. What is the ratio of the Primary completion rate (% of total enrollments) in Nicaragua in 2002 to that in 2003?
Offer a terse response. 1.02. What is the ratio of the Primary completion rate (% of total enrollments) in Ghana in 2002 to that in 2004?
Keep it short and to the point. 1.04. What is the ratio of the Primary completion rate (% of total enrollments) in Italy in 2002 to that in 2004?
Ensure brevity in your answer.  1.02. What is the ratio of the Primary completion rate (% of total enrollments) of Kuwait in 2002 to that in 2004?
Your answer should be very brief. 0.96. What is the ratio of the Primary completion rate (% of total enrollments) in Nicaragua in 2002 to that in 2004?
Offer a very short reply. 1.03. What is the ratio of the Primary completion rate (% of total enrollments) of Ghana in 2002 to that in 2005?
Your answer should be compact. 0.92. What is the ratio of the Primary completion rate (% of total enrollments) of Italy in 2002 to that in 2005?
Make the answer very short. 1.04. What is the ratio of the Primary completion rate (% of total enrollments) of Kuwait in 2002 to that in 2005?
Ensure brevity in your answer.  0.92. What is the ratio of the Primary completion rate (% of total enrollments) in Nicaragua in 2002 to that in 2005?
Offer a very short reply. 0.99. What is the ratio of the Primary completion rate (% of total enrollments) in Ghana in 2003 to that in 2004?
Offer a very short reply. 1.12. What is the ratio of the Primary completion rate (% of total enrollments) in Italy in 2003 to that in 2004?
Provide a succinct answer. 1.02. What is the ratio of the Primary completion rate (% of total enrollments) in Kuwait in 2003 to that in 2004?
Make the answer very short. 1. What is the ratio of the Primary completion rate (% of total enrollments) in Nicaragua in 2003 to that in 2004?
Provide a succinct answer. 1. What is the ratio of the Primary completion rate (% of total enrollments) of Ghana in 2003 to that in 2005?
Your answer should be very brief. 0.99. What is the ratio of the Primary completion rate (% of total enrollments) of Italy in 2003 to that in 2005?
Make the answer very short. 1.04. What is the ratio of the Primary completion rate (% of total enrollments) of Kuwait in 2003 to that in 2005?
Provide a short and direct response. 0.97. What is the ratio of the Primary completion rate (% of total enrollments) in Ghana in 2004 to that in 2005?
Provide a short and direct response. 0.89. What is the ratio of the Primary completion rate (% of total enrollments) in Italy in 2004 to that in 2005?
Make the answer very short. 1.02. What is the ratio of the Primary completion rate (% of total enrollments) in Kuwait in 2004 to that in 2005?
Ensure brevity in your answer.  0.96. What is the difference between the highest and the second highest Primary completion rate (% of total enrollments) in Ghana?
Offer a terse response. 0.49. What is the difference between the highest and the second highest Primary completion rate (% of total enrollments) of Italy?
Keep it short and to the point. 2.14. What is the difference between the highest and the second highest Primary completion rate (% of total enrollments) of Kuwait?
Provide a short and direct response. 0.66. What is the difference between the highest and the second highest Primary completion rate (% of total enrollments) of Nicaragua?
Offer a very short reply. 0.41. What is the difference between the highest and the lowest Primary completion rate (% of total enrollments) of Ghana?
Ensure brevity in your answer.  8.11. What is the difference between the highest and the lowest Primary completion rate (% of total enrollments) of Italy?
Offer a very short reply. 6.43. What is the difference between the highest and the lowest Primary completion rate (% of total enrollments) of Kuwait?
Give a very brief answer. 14.07. What is the difference between the highest and the lowest Primary completion rate (% of total enrollments) of Nicaragua?
Your answer should be compact. 7.54. 